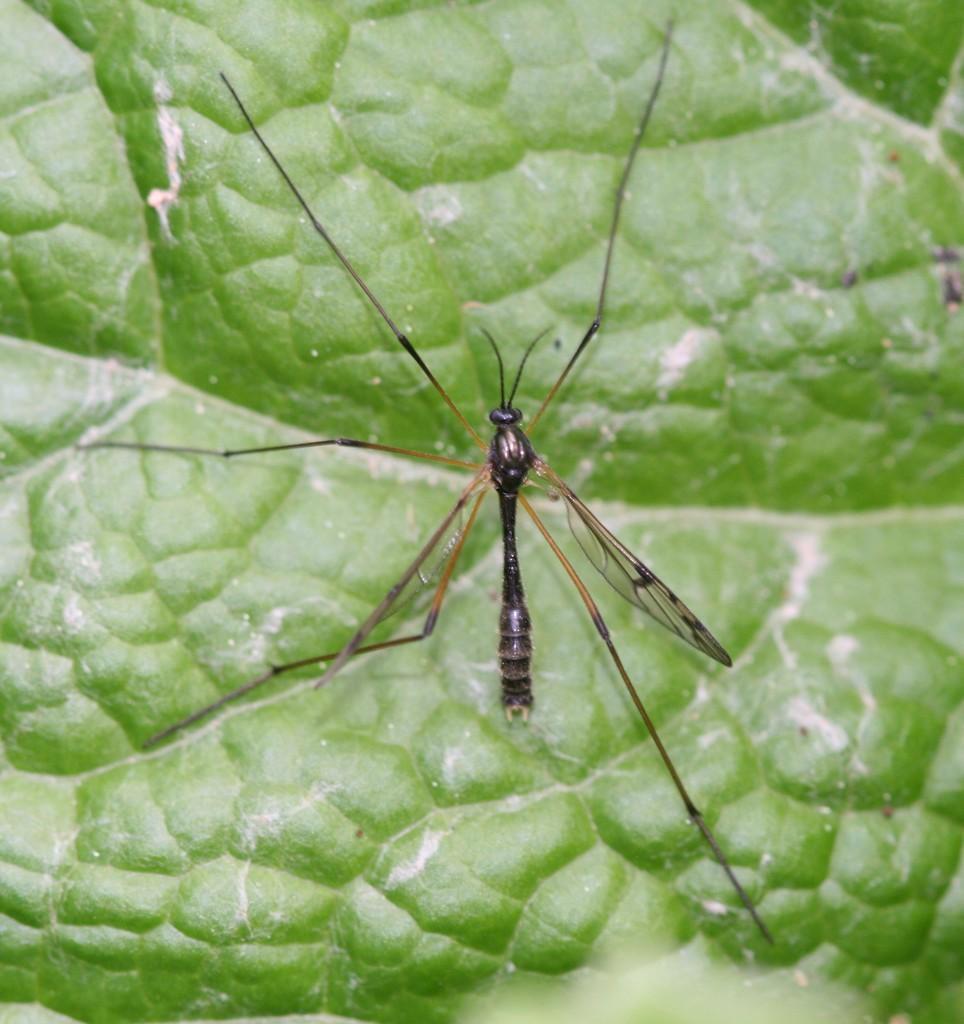Please provide a concise description of this image. In the image we can see there is an insect sitting on the leaf. 